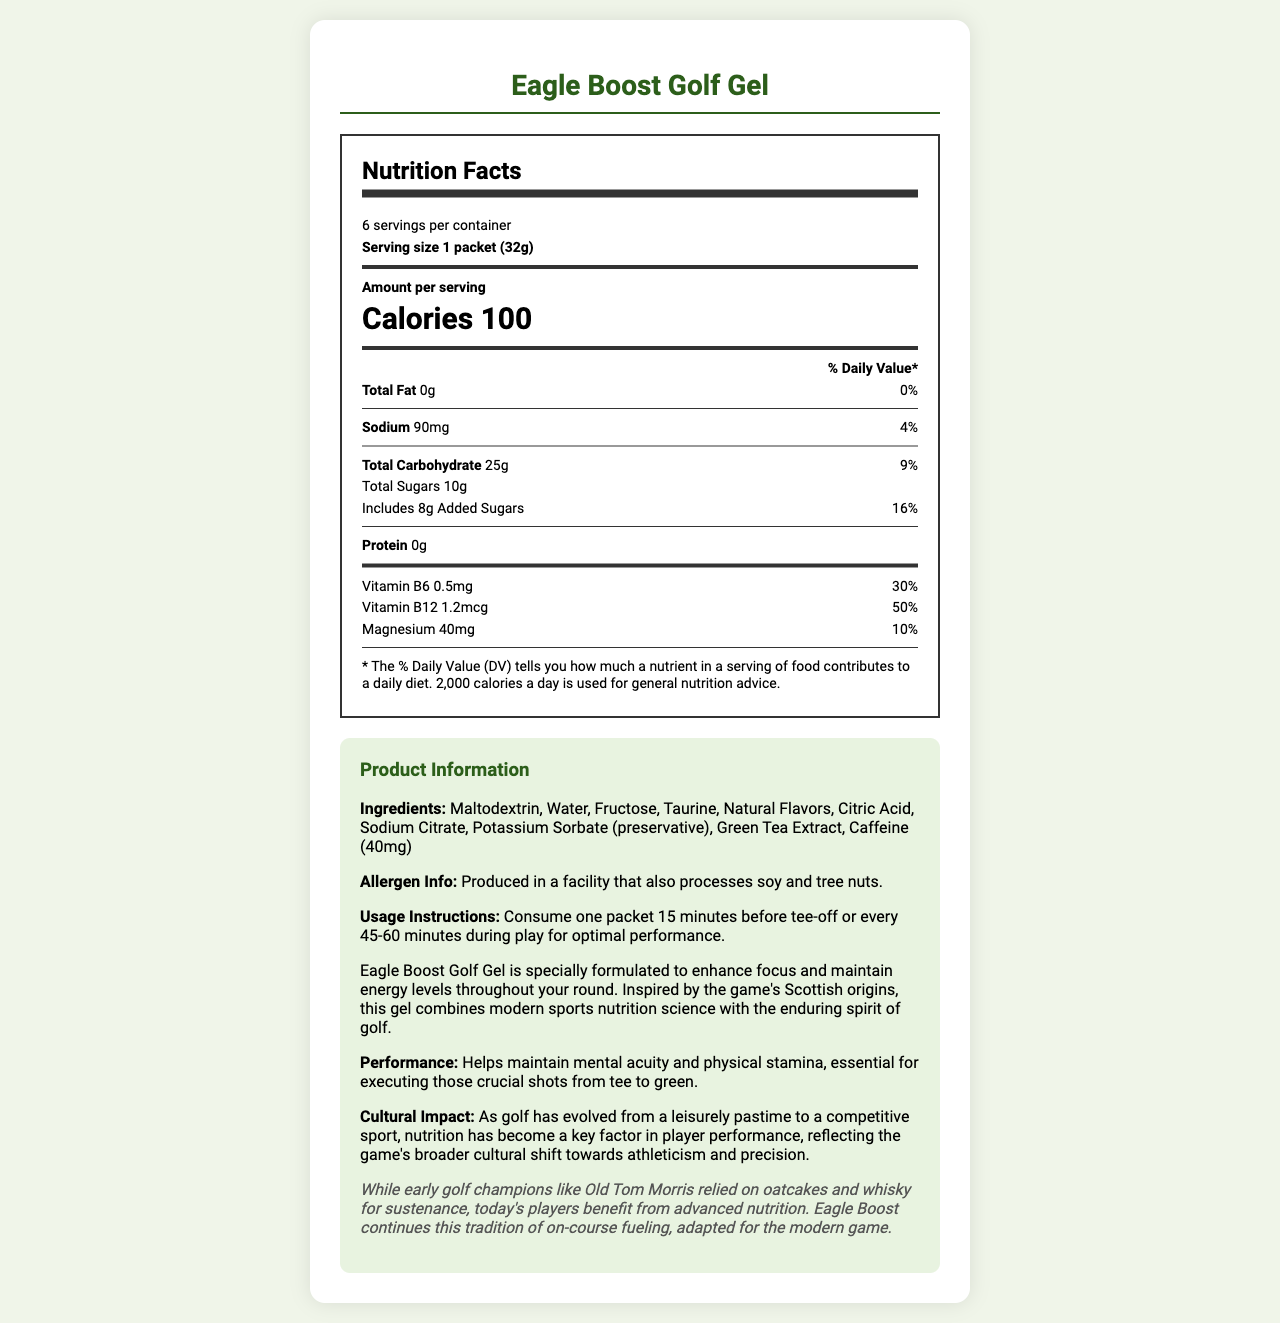what is the serving size for Eagle Boost Golf Gel? The serving size is mentioned as "1 packet (32g)" in the Nutrition Facts section.
Answer: 1 packet (32g) how many servings are in each container of Eagle Boost Golf Gel? The document states "6 servings per container."
Answer: 6 how much Vitamin B12 does each serving of Eagle Boost Golf Gel contain? The amount of Vitamin B12 is listed as "1.2mcg" in the Nutrition Facts section.
Answer: 1.2mcg what is the percentage daily value of Magnesium in one serving? The daily value percentage for Magnesium is stated as "10%" in the vitamins and minerals section.
Answer: 10% how many calories are in one serving of Eagle Boost Golf Gel? The document states "Calories 100" in the Nutrition Facts section.
Answer: 100 when is the optimal time to consume Eagle Boost Golf Gel according to the usage instructions? The usage instructions mention consuming one packet "15 minutes before tee-off or every 45-60 minutes during play."
Answer: 15 minutes before tee-off or every 45-60 minutes during play what is the amount of protein in Eagle Boost Golf Gel? A. 0g B. 5g C. 10g D. 1g The Nutrition Facts state that the amount of protein is "0g."
Answer: A. 0g which allergen is mentioned in the document? I. Soy II. Peanuts III. Tree nuts IV. Dairy The allergen information mentions "soy" and "tree nuts."
Answer: I and III is the nutrition information based on a 2,000 calorie a day diet? The document states "* The % Daily Value (DV) tells you how much a nutrient in a serving of food contributes to a daily diet. 2,000 calories a day is used for general nutrition advice."
Answer: Yes summarize the main idea of the document. The document provides detailed nutrition facts, ingredients, usage instructions, a product description, historical note, and highlights the cultural impact of modern nutrition in golf.
Answer: Eagle Boost Golf Gel is a specialty energy gel designed for golfers to maintain focus and energy levels throughout their round. It contains essential nutrients and vitamins beneficial for performance, comes with clear usage instructions, and connects modern sports nutrition with the historical and cultural aspects of golf. how much caffeine is in each packet of Eagle Boost Golf Gel? The ingredients list includes "Caffeine (40mg)."
Answer: 40mg which vitamins and minerals are listed with their daily value percentages? The document lists Vitamin B6, Vitamin B12, and Magnesium with their respective daily values of "30%", "50%", and "10%."
Answer: Vitamin B6 (30%), Vitamin B12 (50%), Magnesium (10%) what type of flavors are used in Eagle Boost Golf Gel? The ingredients list mentions "Natural Flavors."
Answer: Natural Flavors who is an early golf champion mentioned in the historical note? The historical note refers to "early golf champions like Old Tom Morris."
Answer: Old Tom Morris is Eagle Boost Golf Gel produced in a facility that processes dairy? The allergen information states it is produced in a facility that also processes soy and tree nuts, but there is no mention of dairy.
Answer: Not enough information 